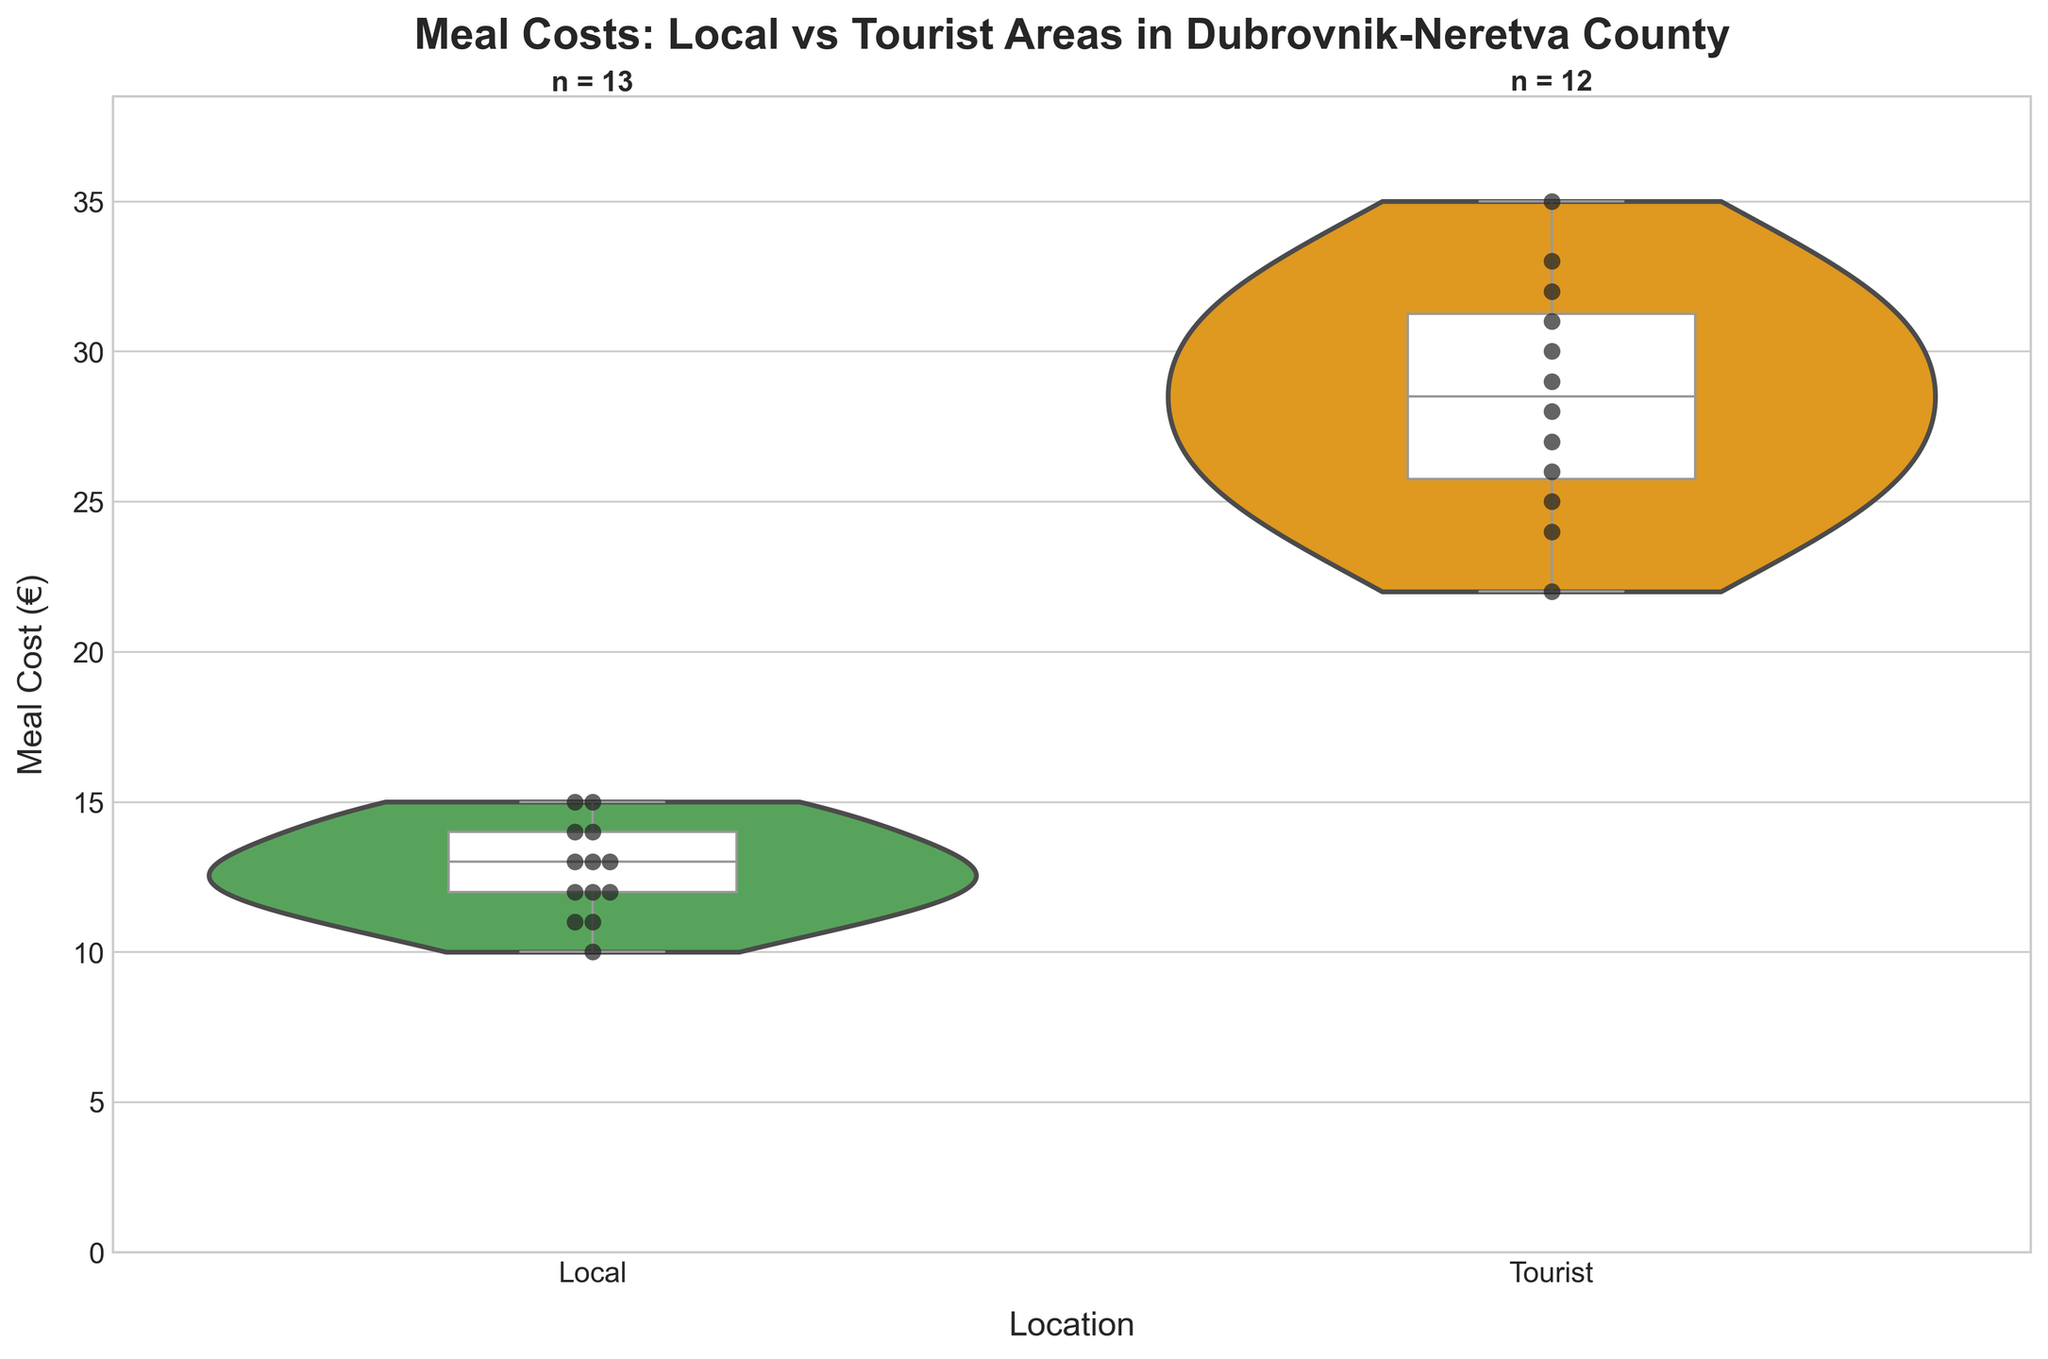What's the title of the chart? The title of the chart is displayed prominently at the top and reads "Meal Costs: Local vs Tourist Areas in Dubrovnik-Neretva County".
Answer: Meal Costs: Local vs Tourist Areas in Dubrovnik-Neretva County What locations are compared in the chart? The x-axis of the chart lists the locations being compared, which are 'Local' and 'Tourist'.
Answer: Local, Tourist How many data points are there for local areas? The text annotation above the 'Local' violin plot indicates the number of data points for local areas with 'n = …'.
Answer: 13 Which location has higher median meal costs? The box plot overlay shows the median as a horizontal line within each violin plot. By comparing the median lines, we can see that the 'Tourist' area has a higher median meal cost than the 'Local' area.
Answer: Tourist What is the color coding used for the locations? The violin plots use different colors for 'Local' and 'Tourist' areas. 'Local' is represented in green, and 'Tourist' is represented in orange.
Answer: Local: green, Tourist: orange What's the range of meal costs in tourist areas? The range can be determined by the extent of the violin plot and the box plot whiskers. It goes from the minimum to the maximum value. The chart shows the tourist meal costs ranging from €22 to €35.
Answer: €22 to €35 Which location shows more variation in meal costs? Variation in the data can be assessed by the width and spread of the violin plots. The 'Tourist' area shows a wider and more spread violin plot than the 'Local' area, indicating more variation in meal costs.
Answer: Tourist What are the maximum meal costs observed in each location? The top of the box plot whiskers shows the maximum meal cost. For 'Local,' it is around €15, and for 'Tourist,' it is around €35.
Answer: Local: €15, Tourist: €35 How does the density of meal costs differ between the two locations? The width of the violin plot at different meal cost values indicates density. The 'Local' area has a denser central region near €12-€14, whereas the 'Tourist' area shows a density spread across €22-€35.
Answer: Local: denser near €12-€14, Tourist: spread across €22-€35 What does the box plot within the violin plot represent? The box plot shows the median (middle line), the interquartile range (the box), and the whiskers representing the data within 1.5 times the interquartile range from the quartiles (excluding outliers). The hollow part marks the density distribution of the data.
Answer: Median, interquartile range, whiskers (excluding outliers) Which area has more meal cost entries below €15? The swarm plot dots and the distribution in the violin plot indicate the number of entries below €15. All entries in the 'Local' area are below €15, whereas the 'Tourist' area has none.
Answer: Local 